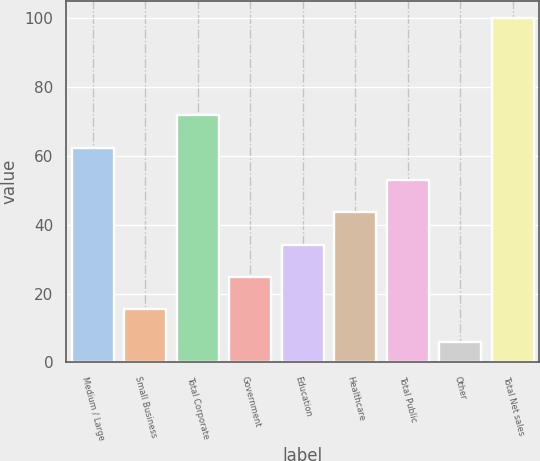<chart> <loc_0><loc_0><loc_500><loc_500><bar_chart><fcel>Medium / Large<fcel>Small Business<fcel>Total Corporate<fcel>Government<fcel>Education<fcel>Healthcare<fcel>Total Public<fcel>Other<fcel>Total Net sales<nl><fcel>62.4<fcel>15.4<fcel>71.8<fcel>24.8<fcel>34.2<fcel>43.6<fcel>53<fcel>6<fcel>100<nl></chart> 